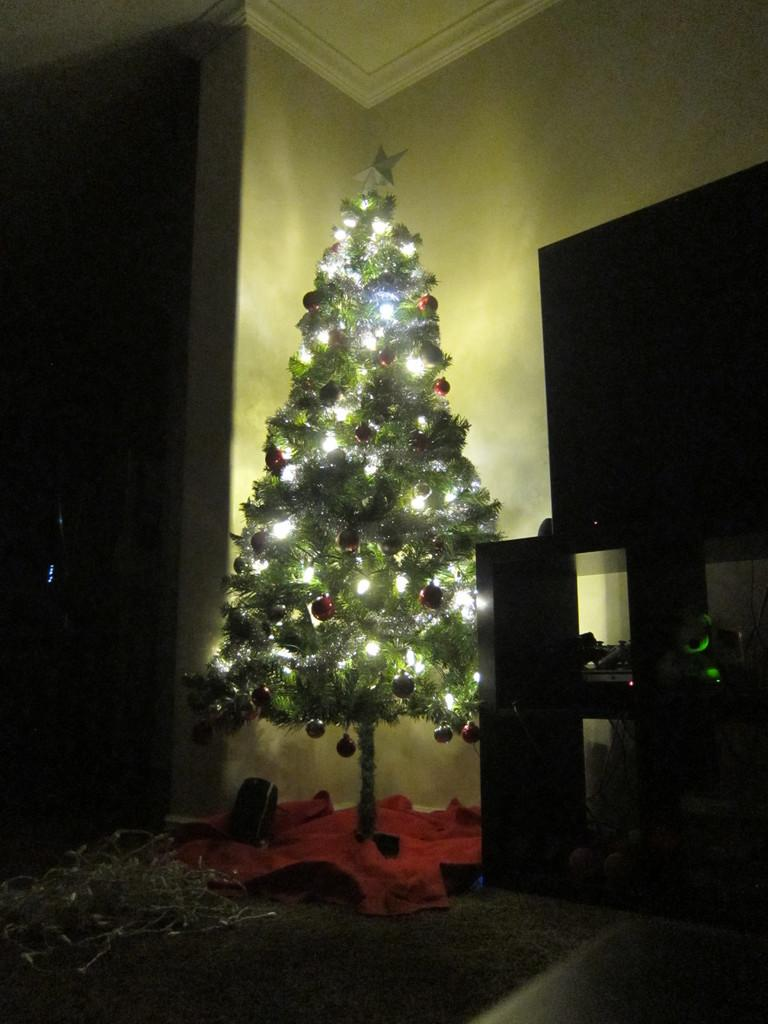What type of tree can be seen inside the room? There is a Christmas tree inside the room. What furniture is present in the room? There is a table in the room. What electronic device is in the room? There is a screen in the room. How would you describe the lighting in the image? The background of the image is dark. What type of net is used to catch the details in the image? There is no net present in the image, and the concept of "catching details" is not applicable to the context of the image. 